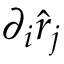Convert formula to latex. <formula><loc_0><loc_0><loc_500><loc_500>\partial _ { i } \hat { r } _ { j }</formula> 